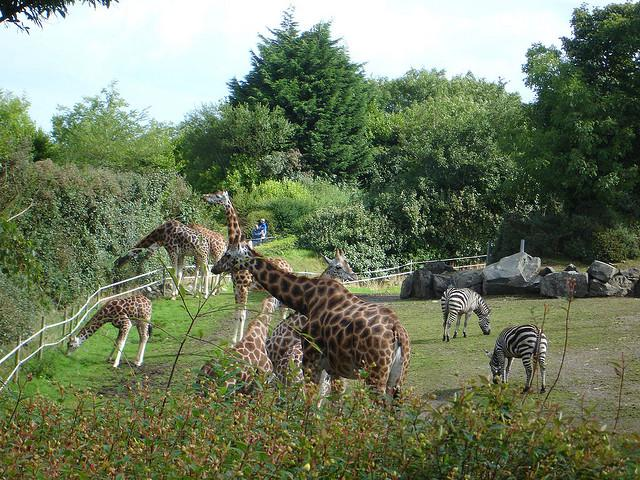How many different species of animals are grazing in the savannah?

Choices:
A) eight
B) two
C) one
D) seven two 